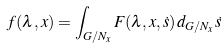Convert formula to latex. <formula><loc_0><loc_0><loc_500><loc_500>f ( \lambda , x ) = \int _ { G / N _ { x } } F ( \lambda , x , \dot { s } ) \, d _ { G / N _ { x } } \dot { s }</formula> 